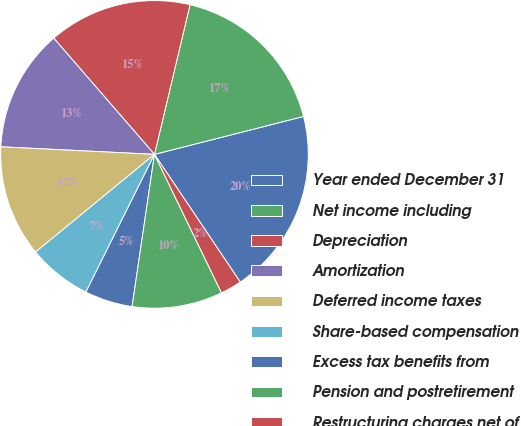<chart> <loc_0><loc_0><loc_500><loc_500><pie_chart><fcel>Year ended December 31<fcel>Net income including<fcel>Depreciation<fcel>Amortization<fcel>Deferred income taxes<fcel>Share-based compensation<fcel>Excess tax benefits from<fcel>Pension and postretirement<fcel>Restructuring charges net of<nl><fcel>19.55%<fcel>17.32%<fcel>15.08%<fcel>12.85%<fcel>11.73%<fcel>6.7%<fcel>5.03%<fcel>9.5%<fcel>2.24%<nl></chart> 